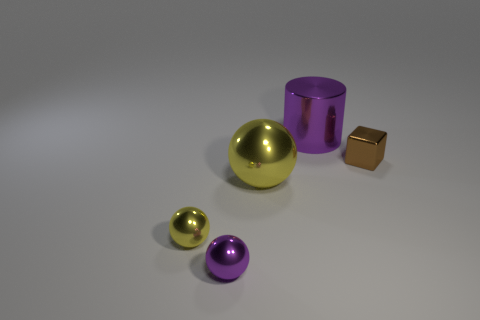Add 3 rubber spheres. How many objects exist? 8 Subtract all spheres. How many objects are left? 2 Subtract all small gray metal things. Subtract all spheres. How many objects are left? 2 Add 5 big purple metallic objects. How many big purple metallic objects are left? 6 Add 1 purple things. How many purple things exist? 3 Subtract 0 red spheres. How many objects are left? 5 